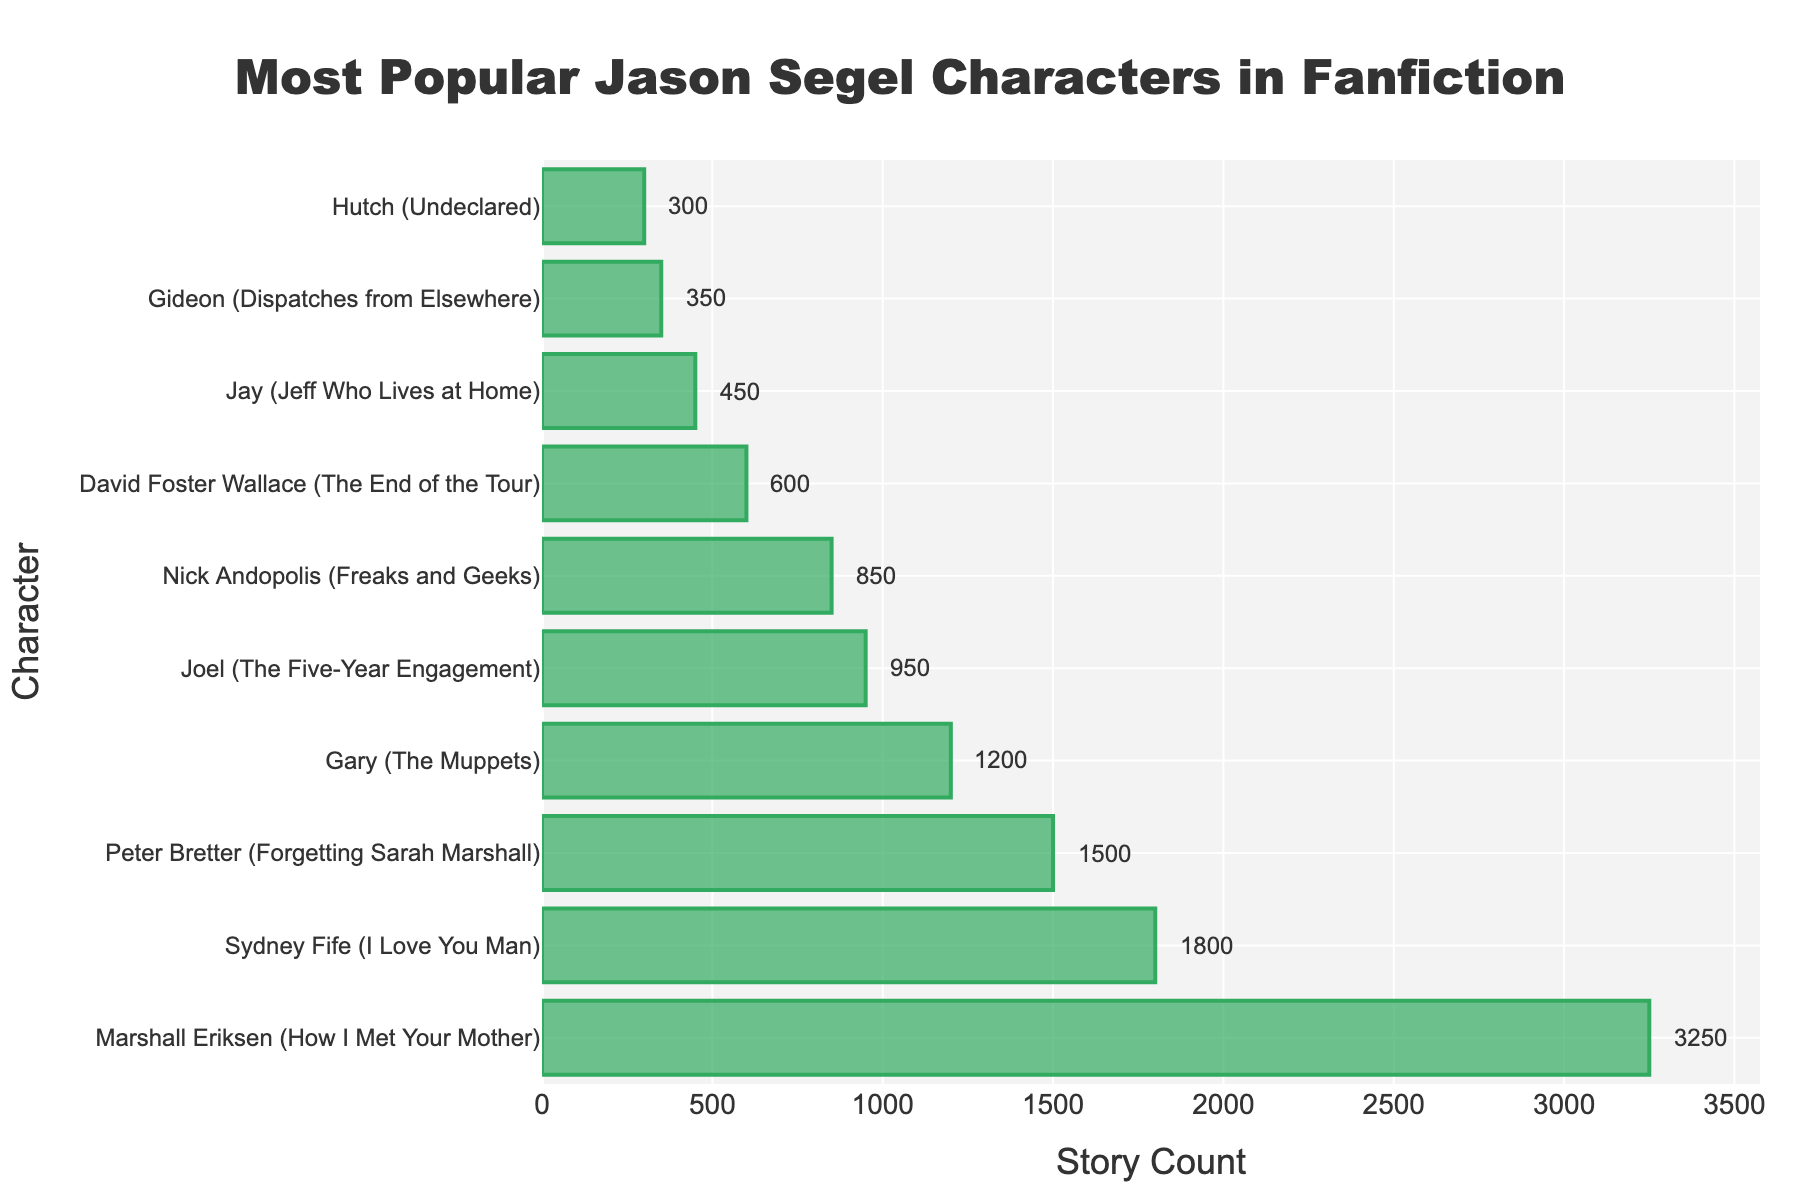Which character has the highest story count? The bar representing Marshall Eriksen (How I Met Your Mother) is the tallest and has the highest value annotated.
Answer: Marshall Eriksen (How I Met Your Mother) What is the total story count for the three least popular characters? The three least popular characters are Gideon (350), Jay (450), and Hutch (300). Summing them: 350 + 450 + 300 = 1100.
Answer: 1100 How many more stories does Marshall Eriksen have than Sydney Fife? Marshall Eriksen has 3250 stories, and Sydney Fife has 1800. Subtracting: 3250 - 1800 = 1450.
Answer: 1450 Which character has a higher story count: Peter Bretter or Gary? Peter Bretter has 1500 stories, while Gary has 1200. 1500 is greater than 1200.
Answer: Peter Bretter What is the difference in story count between Joel and Nick Andopolis? Joel has 950 stories, and Nick Andopolis has 850. Subtracting: 950 - 850 = 100.
Answer: 100 What is the average story count of the top five characters? The top five characters are Marshall Eriksen (3250), Sydney Fife (1800), Peter Bretter (1500), Gary (1200), and Joel (950). The sum is 3250 + 1800 + 1500 + 1200 + 950 = 8700. Dividing by 5: 8700 / 5 = 1740.
Answer: 1740 How many characters have a story count higher than 1000? The characters with story counts higher than 1000 are Marshall Eriksen, Sydney Fife, Peter Bretter, and Gary. There are 4 such characters.
Answer: 4 By how much does David Foster Wallace's story count exceed Gideon's? David Foster Wallace has 600 stories, and Gideon has 350. Subtracting: 600 - 350 = 250.
Answer: 250 